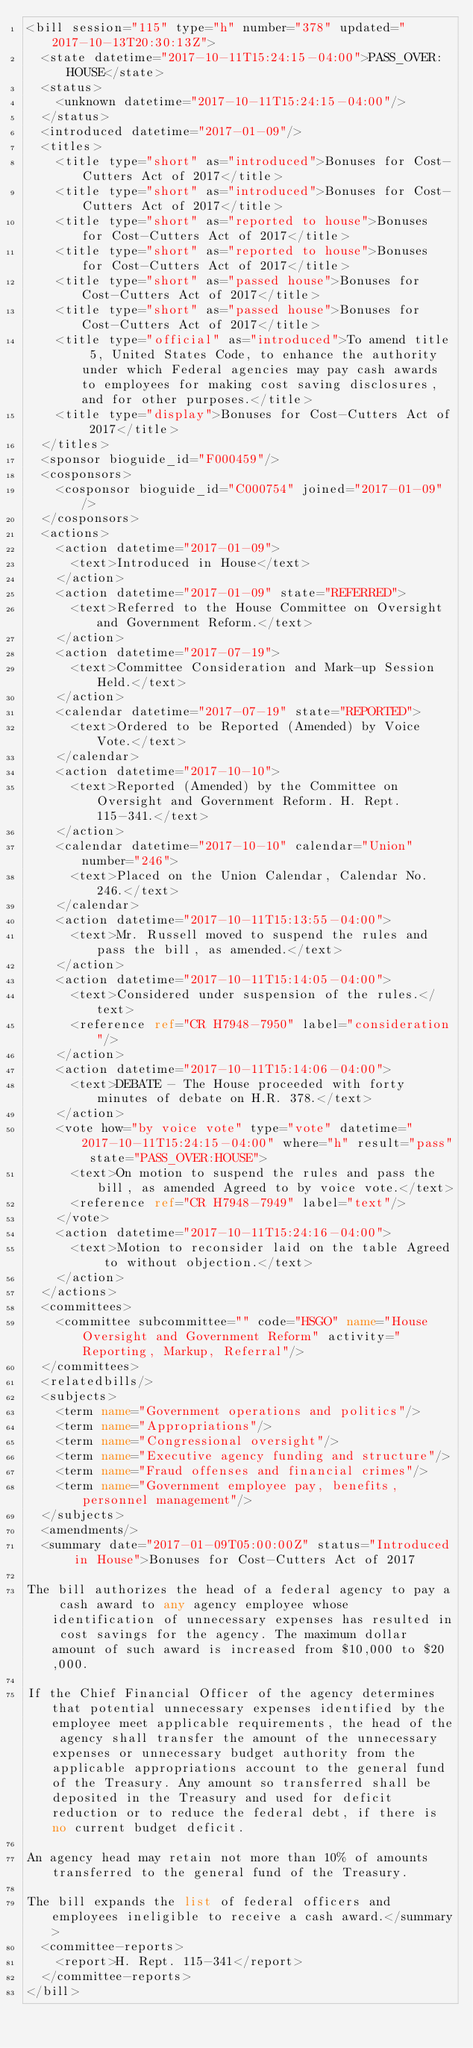Convert code to text. <code><loc_0><loc_0><loc_500><loc_500><_XML_><bill session="115" type="h" number="378" updated="2017-10-13T20:30:13Z">
  <state datetime="2017-10-11T15:24:15-04:00">PASS_OVER:HOUSE</state>
  <status>
    <unknown datetime="2017-10-11T15:24:15-04:00"/>
  </status>
  <introduced datetime="2017-01-09"/>
  <titles>
    <title type="short" as="introduced">Bonuses for Cost-Cutters Act of 2017</title>
    <title type="short" as="introduced">Bonuses for Cost-Cutters Act of 2017</title>
    <title type="short" as="reported to house">Bonuses for Cost-Cutters Act of 2017</title>
    <title type="short" as="reported to house">Bonuses for Cost-Cutters Act of 2017</title>
    <title type="short" as="passed house">Bonuses for Cost-Cutters Act of 2017</title>
    <title type="short" as="passed house">Bonuses for Cost-Cutters Act of 2017</title>
    <title type="official" as="introduced">To amend title 5, United States Code, to enhance the authority under which Federal agencies may pay cash awards to employees for making cost saving disclosures, and for other purposes.</title>
    <title type="display">Bonuses for Cost-Cutters Act of 2017</title>
  </titles>
  <sponsor bioguide_id="F000459"/>
  <cosponsors>
    <cosponsor bioguide_id="C000754" joined="2017-01-09"/>
  </cosponsors>
  <actions>
    <action datetime="2017-01-09">
      <text>Introduced in House</text>
    </action>
    <action datetime="2017-01-09" state="REFERRED">
      <text>Referred to the House Committee on Oversight and Government Reform.</text>
    </action>
    <action datetime="2017-07-19">
      <text>Committee Consideration and Mark-up Session Held.</text>
    </action>
    <calendar datetime="2017-07-19" state="REPORTED">
      <text>Ordered to be Reported (Amended) by Voice Vote.</text>
    </calendar>
    <action datetime="2017-10-10">
      <text>Reported (Amended) by the Committee on Oversight and Government Reform. H. Rept. 115-341.</text>
    </action>
    <calendar datetime="2017-10-10" calendar="Union" number="246">
      <text>Placed on the Union Calendar, Calendar No. 246.</text>
    </calendar>
    <action datetime="2017-10-11T15:13:55-04:00">
      <text>Mr. Russell moved to suspend the rules and pass the bill, as amended.</text>
    </action>
    <action datetime="2017-10-11T15:14:05-04:00">
      <text>Considered under suspension of the rules.</text>
      <reference ref="CR H7948-7950" label="consideration"/>
    </action>
    <action datetime="2017-10-11T15:14:06-04:00">
      <text>DEBATE - The House proceeded with forty minutes of debate on H.R. 378.</text>
    </action>
    <vote how="by voice vote" type="vote" datetime="2017-10-11T15:24:15-04:00" where="h" result="pass" state="PASS_OVER:HOUSE">
      <text>On motion to suspend the rules and pass the bill, as amended Agreed to by voice vote.</text>
      <reference ref="CR H7948-7949" label="text"/>
    </vote>
    <action datetime="2017-10-11T15:24:16-04:00">
      <text>Motion to reconsider laid on the table Agreed to without objection.</text>
    </action>
  </actions>
  <committees>
    <committee subcommittee="" code="HSGO" name="House Oversight and Government Reform" activity="Reporting, Markup, Referral"/>
  </committees>
  <relatedbills/>
  <subjects>
    <term name="Government operations and politics"/>
    <term name="Appropriations"/>
    <term name="Congressional oversight"/>
    <term name="Executive agency funding and structure"/>
    <term name="Fraud offenses and financial crimes"/>
    <term name="Government employee pay, benefits, personnel management"/>
  </subjects>
  <amendments/>
  <summary date="2017-01-09T05:00:00Z" status="Introduced in House">Bonuses for Cost-Cutters Act of 2017

The bill authorizes the head of a federal agency to pay a cash award to any agency employee whose identification of unnecessary expenses has resulted in cost savings for the agency. The maximum dollar amount of such award is increased from $10,000 to $20,000.

If the Chief Financial Officer of the agency determines that potential unnecessary expenses identified by the employee meet applicable requirements, the head of the agency shall transfer the amount of the unnecessary expenses or unnecessary budget authority from the applicable appropriations account to the general fund of the Treasury. Any amount so transferred shall be deposited in the Treasury and used for deficit reduction or to reduce the federal debt, if there is no current budget deficit.

An agency head may retain not more than 10% of amounts transferred to the general fund of the Treasury.

The bill expands the list of federal officers and employees ineligible to receive a cash award.</summary>
  <committee-reports>
    <report>H. Rept. 115-341</report>
  </committee-reports>
</bill>
</code> 